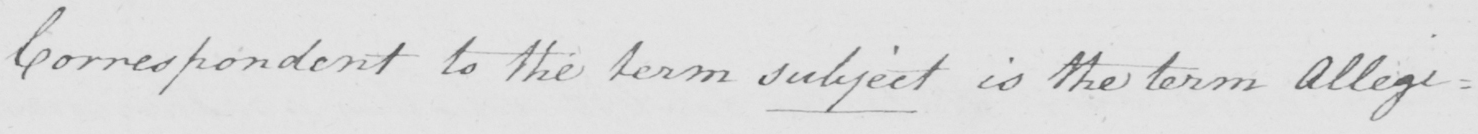What text is written in this handwritten line? Correspondent to the term subject is the term Allegi= 